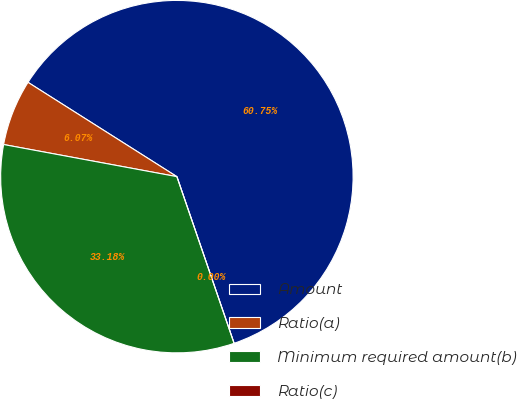Convert chart. <chart><loc_0><loc_0><loc_500><loc_500><pie_chart><fcel>Amount<fcel>Ratio(a)<fcel>Minimum required amount(b)<fcel>Ratio(c)<nl><fcel>60.75%<fcel>6.07%<fcel>33.18%<fcel>0.0%<nl></chart> 